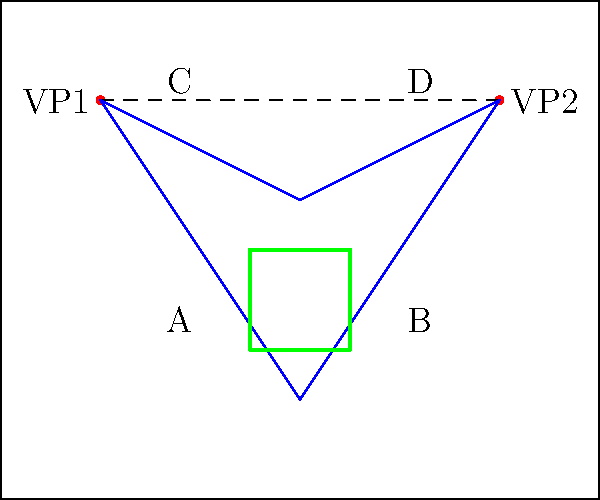In the diagram above, two vanishing points (VP1 and VP2) are shown on the horizon line of a medieval painting. Which of the labeled regions (A, B, C, or D) represents the correct placement for a rectangular object to maintain proper perspective according to these vanishing points? To determine the correct placement of a rectangular object in a medieval painting using two-point perspective, we need to follow these steps:

1. Identify the horizon line: In this case, it's the dashed line connecting VP1 and VP2.

2. Understand the role of vanishing points: All horizontal lines parallel to the picture plane will converge at either VP1 or VP2.

3. Analyze the perspective lines: The blue lines in the diagram represent the perspective lines drawn from each vanishing point.

4. Locate the intersection of perspective lines: The area where these lines intersect will create a shape that follows the rules of perspective.

5. Identify the correct region: The green rectangle in the diagram shows where these perspective lines intersect, creating a properly oriented rectangular shape.

6. Match the region to a label: The green rectangle falls within the region labeled A.

In medieval art, while perspective wasn't always strictly adhered to, understanding these principles helps us analyze and appreciate the development of spatial representation in paintings over time.
Answer: A 